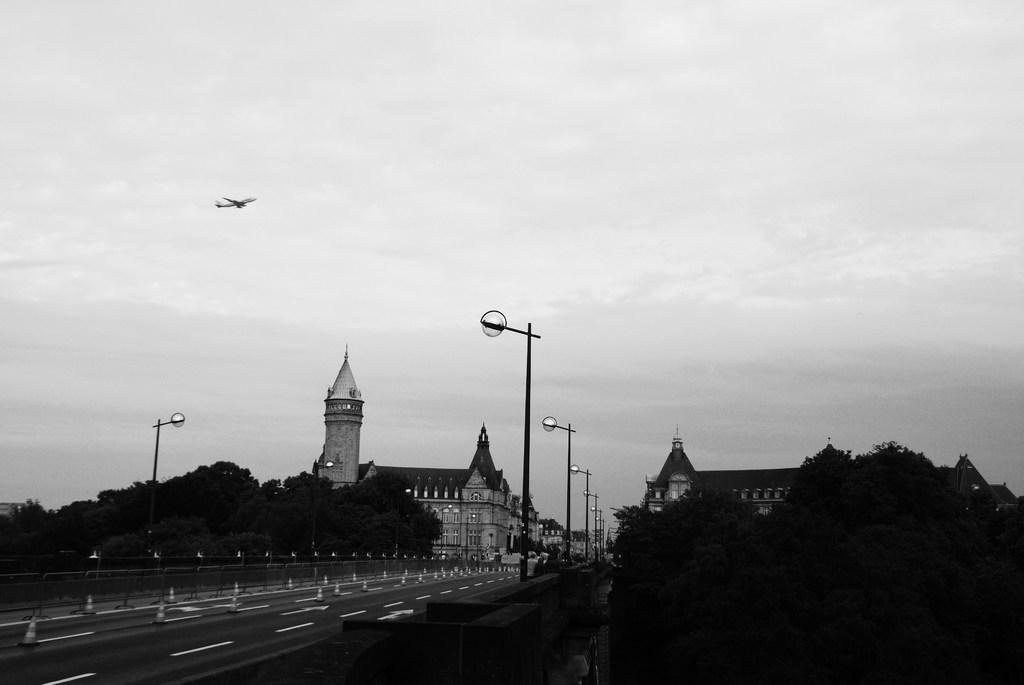What type of vegetation is visible in the front of the image? There are trees in the front of the image. What can be seen in the background of the image? There are poles, buildings, and trees in the background of the image. What is the condition of the sky in the image? The sky is cloudy in the image. Is there any transportation visible in the image? Yes, there is an airplane flying in the sky. What type of toothpaste is being advertised on the poles in the background? There is no toothpaste being advertised on the poles in the background; the poles are not mentioned as having any advertisements or signs. 